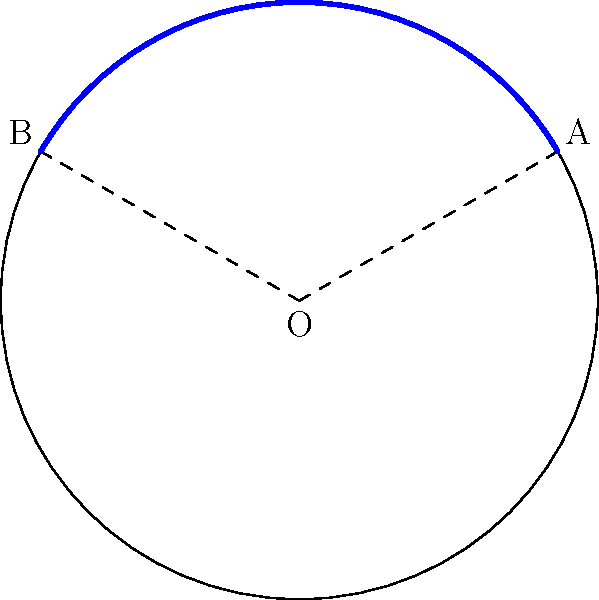At the local playground, you notice a circular merry-go-round with a radius of 3 meters. Your child wants to add colorful tape along a section of its edge, covering an arc that spans 120°. How many meters of tape will you need to purchase for this project? Let's approach this step-by-step:

1) The formula for arc length is:
   
   $s = r\theta$

   Where:
   $s$ is the arc length
   $r$ is the radius
   $\theta$ is the central angle in radians

2) We're given the radius ($r = 3$ meters) and the central angle (120°), but the angle is in degrees. We need to convert it to radians:

   $\theta = 120° \times \frac{\pi}{180°} = \frac{2\pi}{3}$ radians

3) Now we can substitute these values into our formula:

   $s = r\theta = 3 \times \frac{2\pi}{3} = 2\pi$ meters

4) To get a decimal approximation:

   $s \approx 2 \times 3.14159 \approx 6.28$ meters

Therefore, you'll need approximately 6.28 meters of tape for your child's merry-go-round project.
Answer: $2\pi$ meters (or approximately 6.28 meters) 